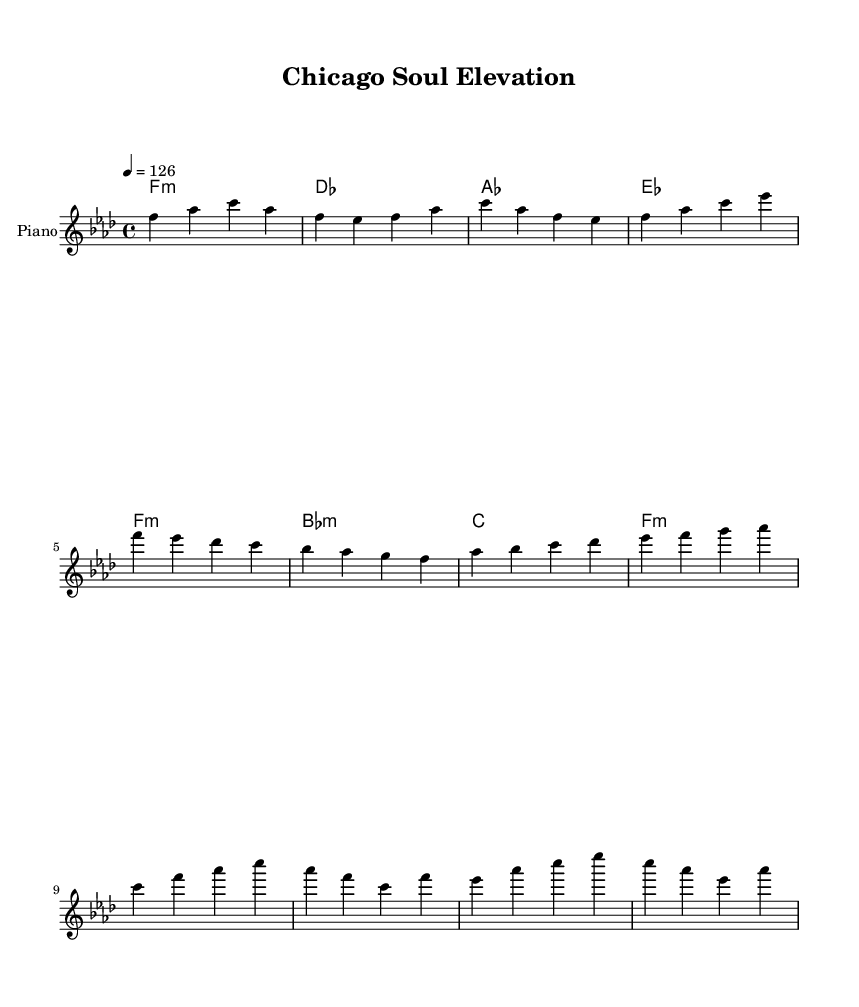What is the key signature of this music? The key signature is F minor, which has four flats. This is determined by the key indication at the beginning of the score, which shows F minor as the tonality.
Answer: F minor What is the time signature of the piece? The time signature of the piece is four-four, indicated by the numeral "4/4" at the beginning of the score. This implies that there are four beats in each measure.
Answer: 4/4 What is the tempo marking for the music? The tempo is marked at a quarter note equals 126, indicated by the "4 = 126" at the start. This shows the speed at which the piece should be played.
Answer: 126 How many measures are in the verse section? There are four measures in the verse section, as seen in the notation specifically laid out before transitioning to the pre-chorus part of the music.
Answer: 4 Which chord is played in the first measure? The first measure features an F minor chord, as indicated by the chord symbol above the staff. This is the first chord in the harmonies section.
Answer: F minor What is the structure type of this music? The music can be identified as structured with verses, a pre-chorus, and a chorus. The layout shows these distinct sections which are typical of song forms, especially in soulful house genres.
Answer: Verse, pre-chorus, chorus What vocal style is associated with this genre? The music features gospel-inspired vocals, reflecting a soulful style that is characteristic of the house genre, enhancing the emotional depth of the composition.
Answer: Gospel-inspired 